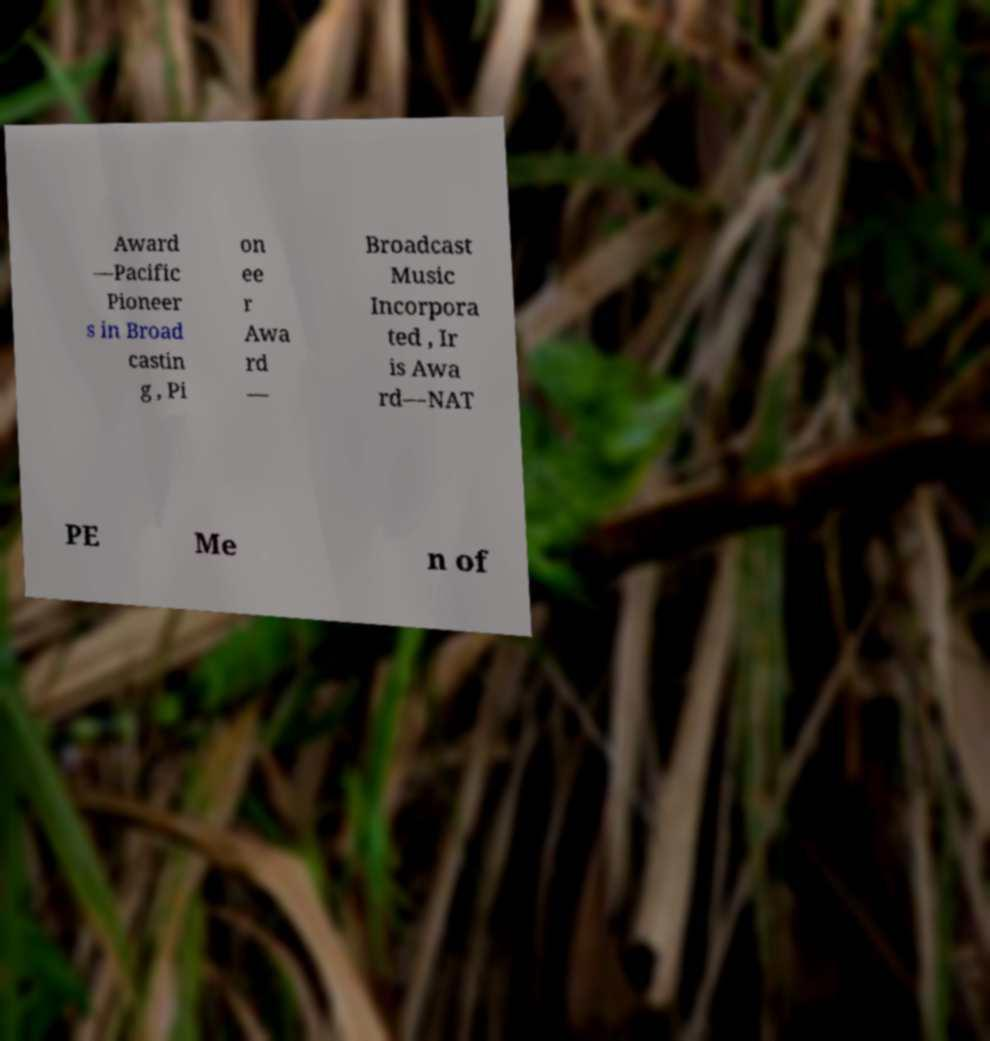Can you accurately transcribe the text from the provided image for me? Award —Pacific Pioneer s in Broad castin g , Pi on ee r Awa rd — Broadcast Music Incorpora ted , Ir is Awa rd—NAT PE Me n of 